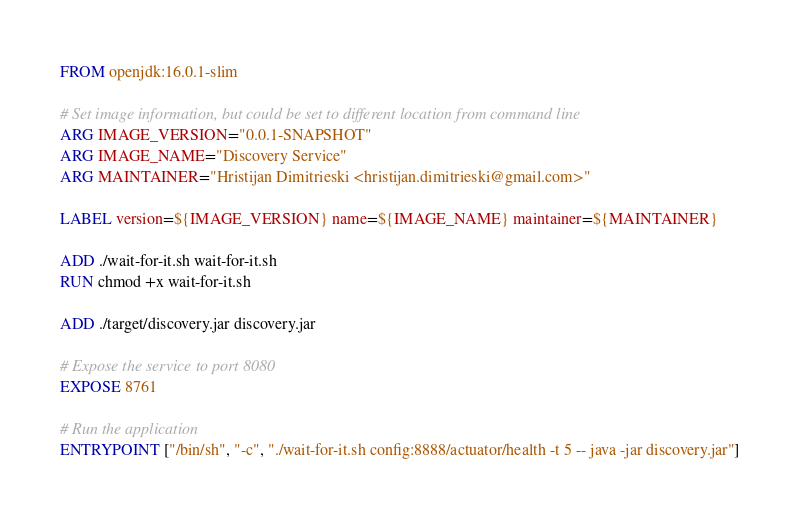<code> <loc_0><loc_0><loc_500><loc_500><_Dockerfile_>FROM openjdk:16.0.1-slim

# Set image information, but could be set to different location from command line
ARG IMAGE_VERSION="0.0.1-SNAPSHOT"
ARG IMAGE_NAME="Discovery Service"
ARG MAINTAINER="Hristijan Dimitrieski <hristijan.dimitrieski@gmail.com>"

LABEL version=${IMAGE_VERSION} name=${IMAGE_NAME} maintainer=${MAINTAINER}

ADD ./wait-for-it.sh wait-for-it.sh
RUN chmod +x wait-for-it.sh

ADD ./target/discovery.jar discovery.jar

# Expose the service to port 8080
EXPOSE 8761

# Run the application
ENTRYPOINT ["/bin/sh", "-c", "./wait-for-it.sh config:8888/actuator/health -t 5 -- java -jar discovery.jar"]
</code> 